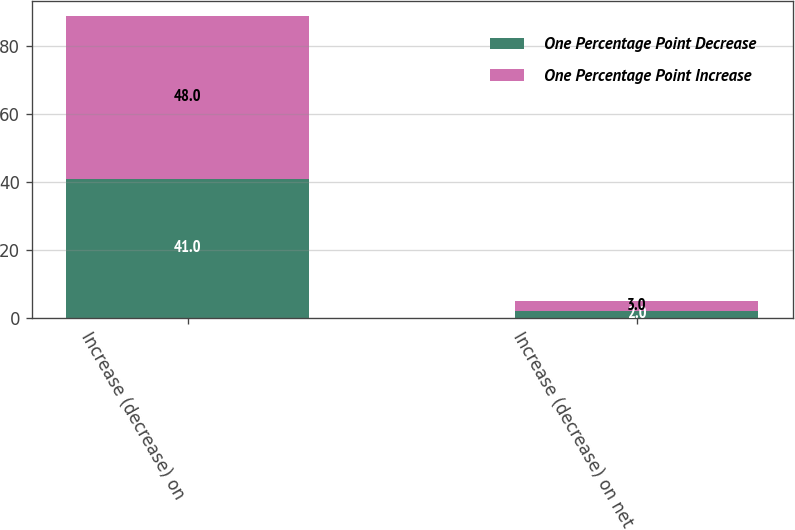Convert chart to OTSL. <chart><loc_0><loc_0><loc_500><loc_500><stacked_bar_chart><ecel><fcel>Increase (decrease) on<fcel>Increase (decrease) on net<nl><fcel>One Percentage Point Decrease<fcel>41<fcel>2<nl><fcel>One Percentage Point Increase<fcel>48<fcel>3<nl></chart> 